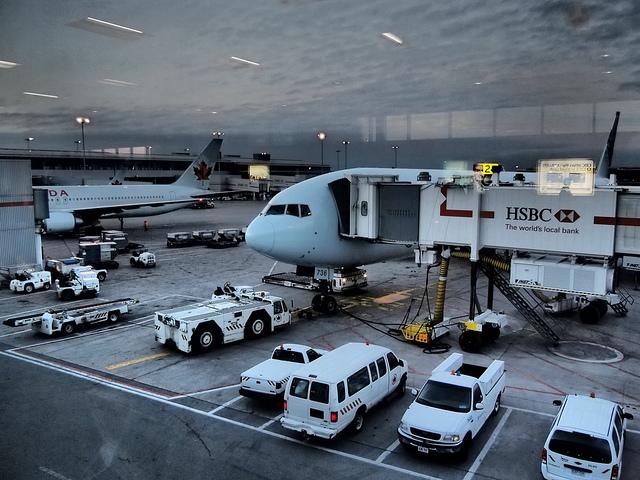How many trucks are there?
Be succinct. 5. Are there trucks in the picture?
Write a very short answer. Yes. How many planes can be seen?
Keep it brief. 2. What type of place is this?
Short answer required. Airport. 